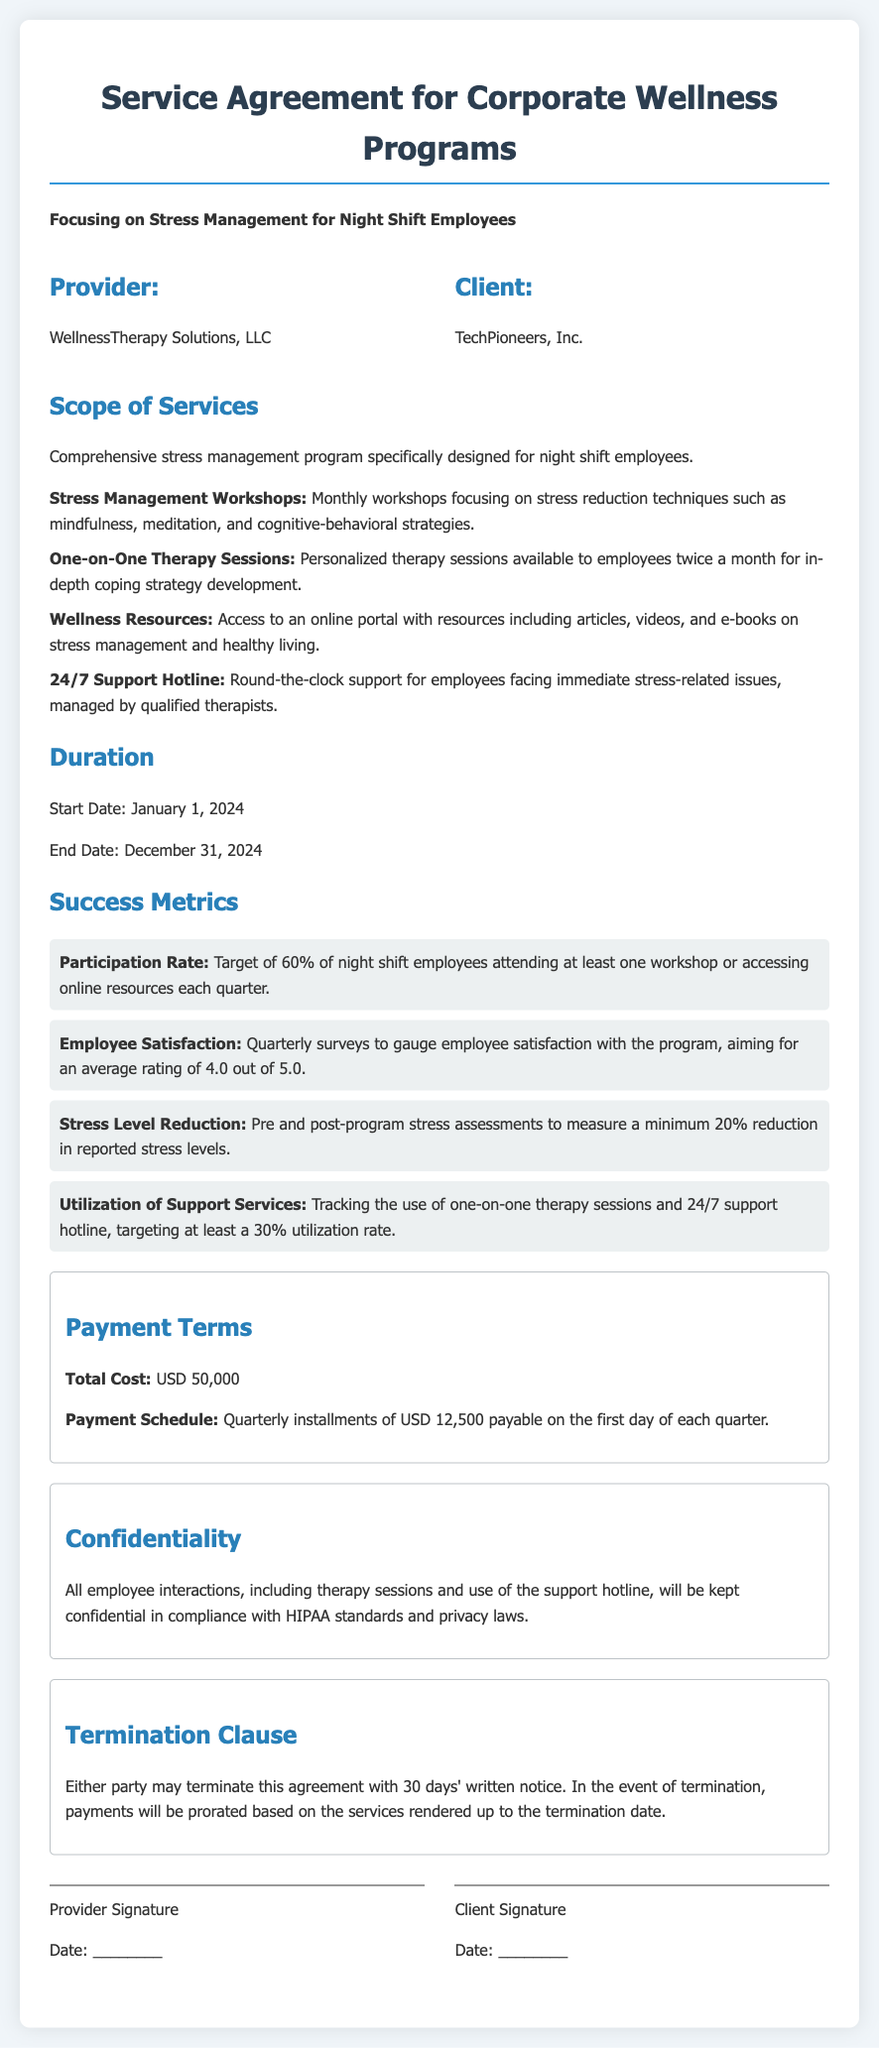What is the name of the provider? The provider is WellnessTherapy Solutions, LLC, which is explicitly stated in the document.
Answer: WellnessTherapy Solutions, LLC What is the duration of the program? The duration is specified with a start date and an end date, which are January 1, 2024, and December 31, 2024, respectively.
Answer: January 1, 2024 - December 31, 2024 What is the total cost of the program? The total cost is mentioned clearly in the payment terms section as USD 50,000.
Answer: USD 50,000 What is the target participation rate? The document states a target participation rate of 60% for night shift employees attending workshops or accessing resources each quarter.
Answer: 60% How often are one-on-one therapy sessions available? The availability of therapy sessions is specified, noting that they are provided twice a month.
Answer: Twice a month What is the minimum required reduction in reported stress levels? The document indicates that a minimum 20% reduction in reported stress levels is the goal to gauge success.
Answer: 20% What type of support is available 24/7? The document mentions a round-the-clock support hotline for employees facing immediate stress-related issues managed by qualified therapists.
Answer: Support hotline What must be provided for termination of the agreement? The document explains that either party must provide 30 days' written notice for termination of the agreement.
Answer: 30 days' written notice 